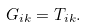Convert formula to latex. <formula><loc_0><loc_0><loc_500><loc_500>G _ { i k } = T _ { i k } .</formula> 